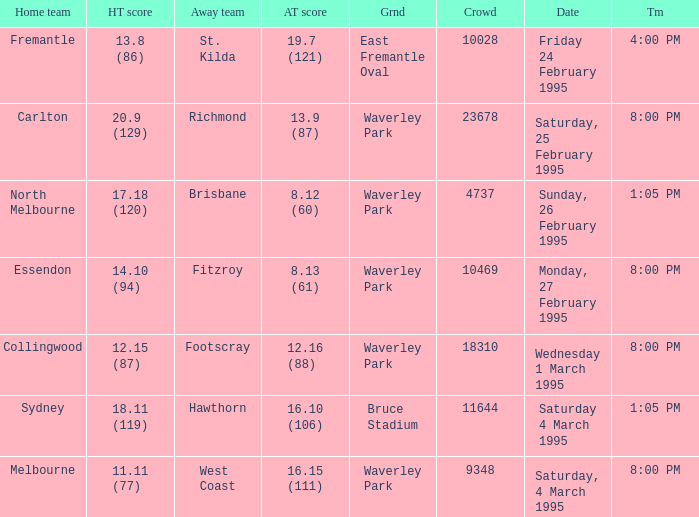Name the time for saturday 4 march 1995 1:05 PM. 